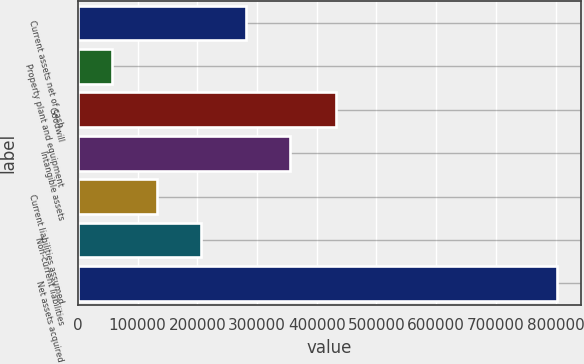Convert chart to OTSL. <chart><loc_0><loc_0><loc_500><loc_500><bar_chart><fcel>Current assets net of cash<fcel>Property plant and equipment<fcel>Goodwill<fcel>Intangible assets<fcel>Current liabilities assumed<fcel>Non-current liabilities<fcel>Net assets acquired<nl><fcel>280764<fcel>57269<fcel>432138<fcel>355263<fcel>131768<fcel>206266<fcel>802254<nl></chart> 